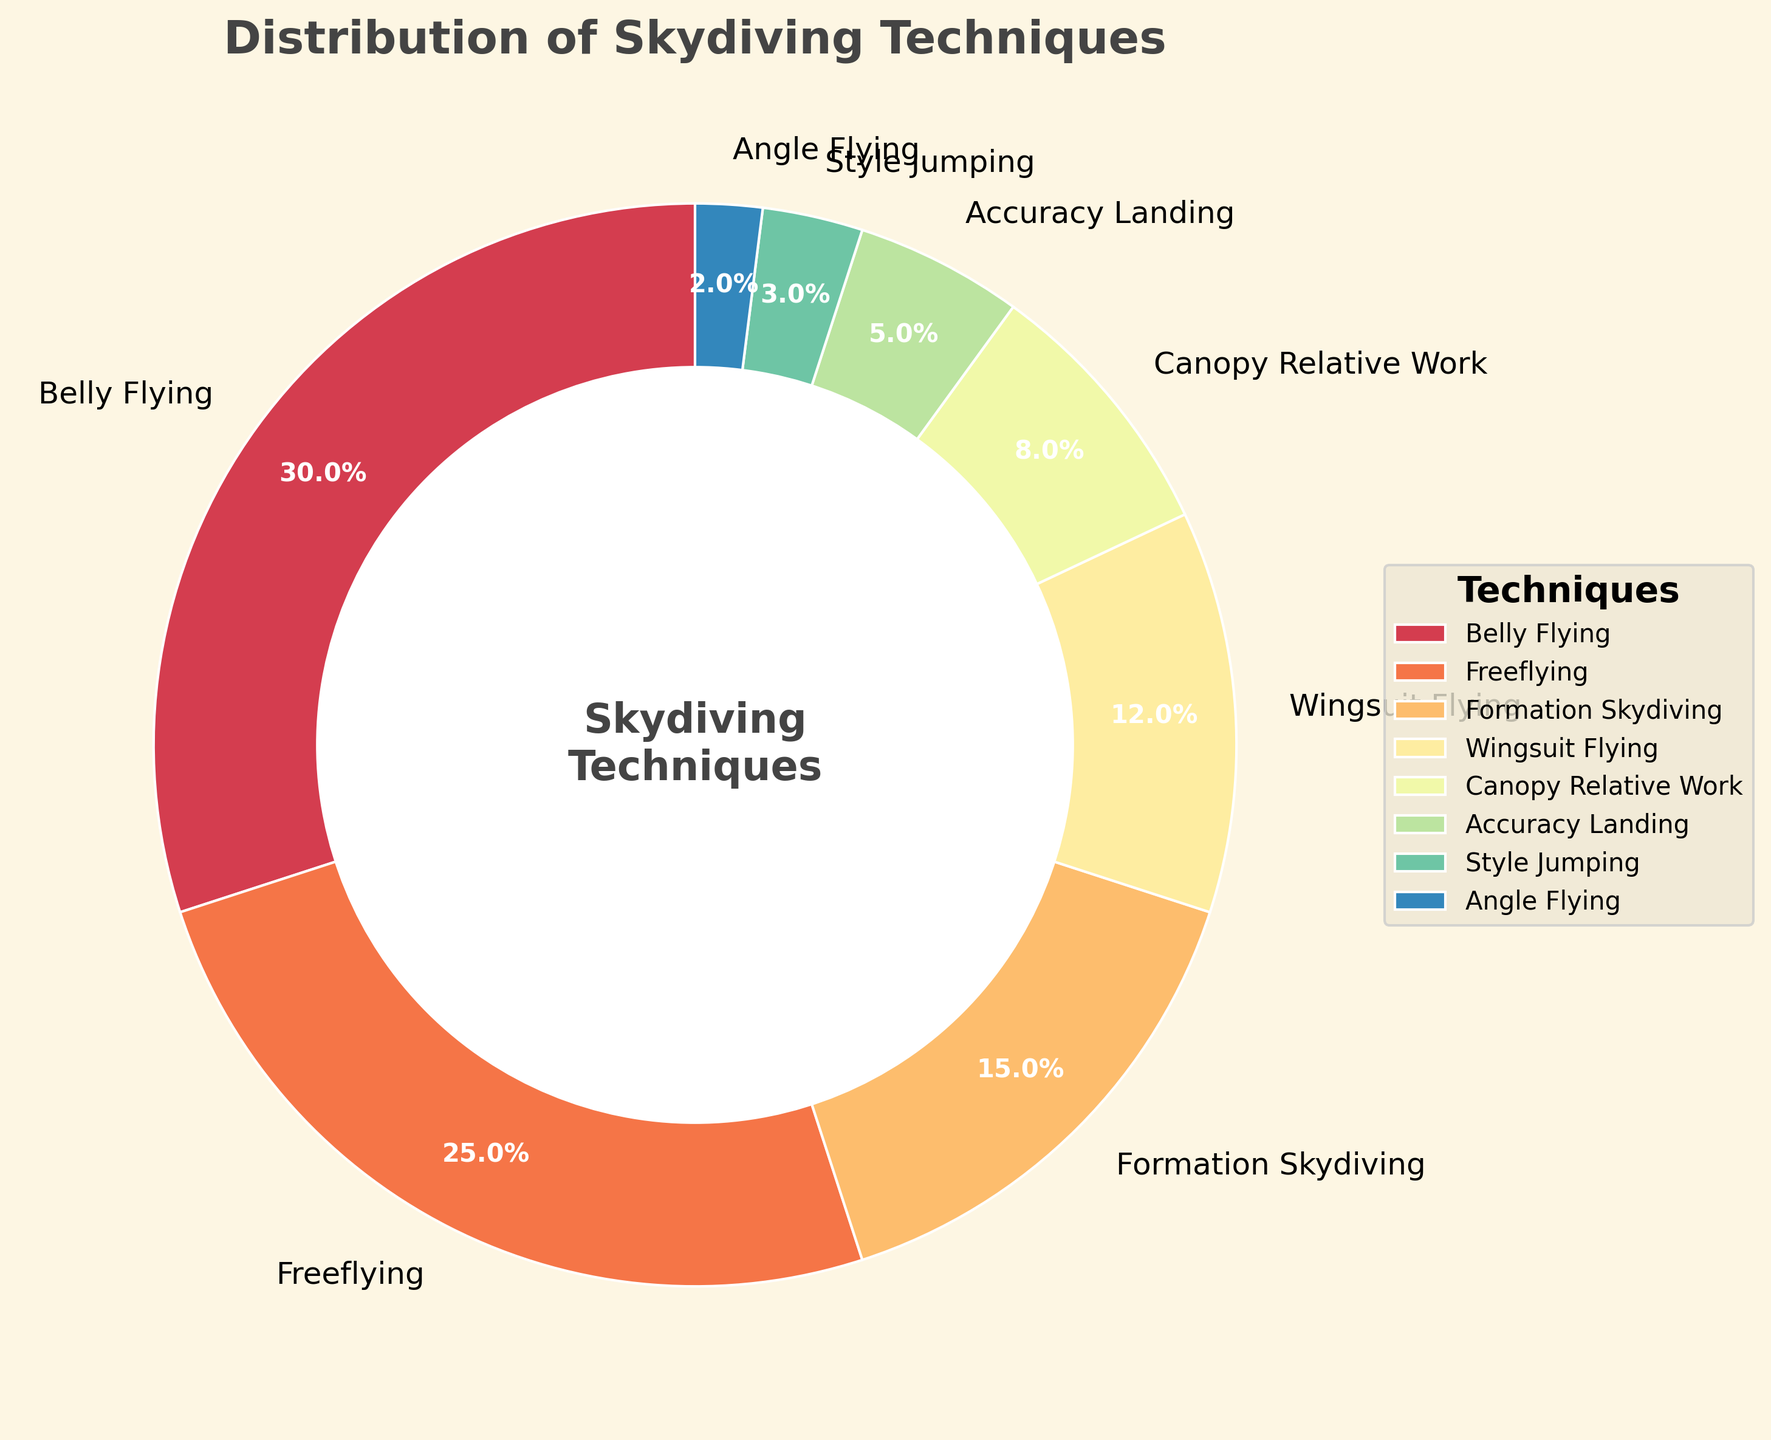what percentage of skydivers prefer belly flying? Locate the "Belly Flying" segment in the pie chart and read its percentage label.
Answer: 30% which skydiving technique is less popular than both wingsuit flying and canopy relative work? Compare the percentage labels of all the techniques. "Accuracy Landing" has 5%, which is less than both "Wingsuit Flying" (12%) and "Canopy Relative Work" (8%).
Answer: Accuracy Landing what is the combined percentage of freeflying and formation skydiving techniques? Add the percentages of "Freeflying" (25%) and "Formation Skydiving" (15%). The combined percentage is 25% + 15% = 40%.
Answer: 40% which is the least used skydiving technique? Identify the segment with the smallest percentage label in the pie chart. "Angle Flying" is the least used technique with 2%.
Answer: Angle Flying does the percentage of belly flying exceed the sum of accuracy landing and style jumping percentages? Compare 30% (Belly Flying) to the sum of "Accuracy Landing" (5%) and "Style Jumping" (3%). 5% + 3% = 8%, which is less than 30%.
Answer: Yes 